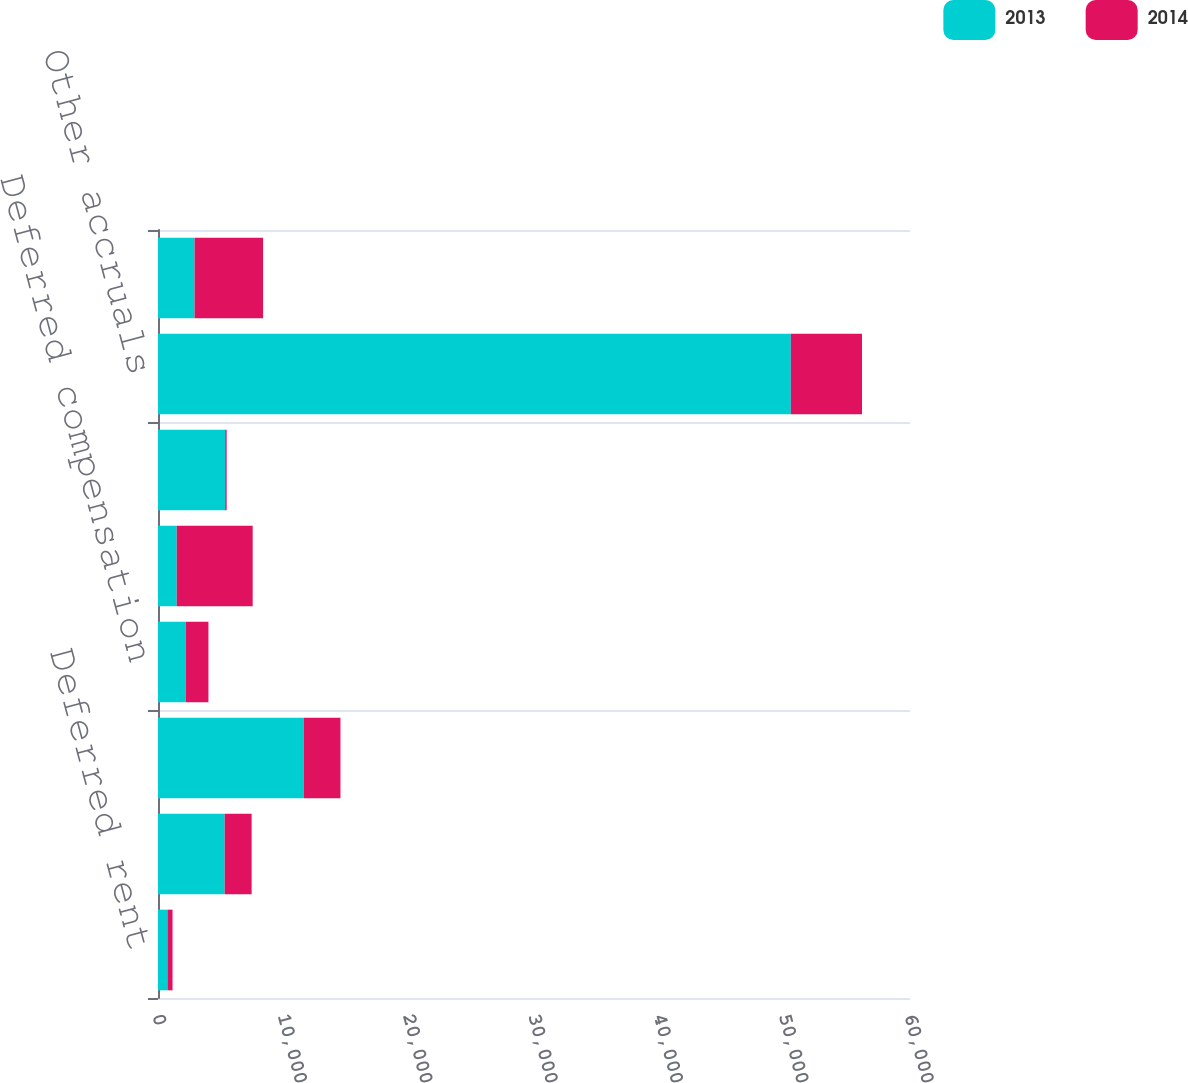Convert chart. <chart><loc_0><loc_0><loc_500><loc_500><stacked_bar_chart><ecel><fcel>Deferred rent<fcel>Accrued vacation<fcel>Accrued bonus<fcel>Deferred compensation<fcel>Inventory items<fcel>Allowance for doubtful<fcel>Other accruals<fcel>Deferred revenue<nl><fcel>2013<fcel>752<fcel>5318<fcel>11642<fcel>2208<fcel>1493<fcel>5361<fcel>50491<fcel>2916<nl><fcel>2014<fcel>409<fcel>2153<fcel>2916<fcel>1816<fcel>6061<fcel>118<fcel>5680<fcel>5469<nl></chart> 